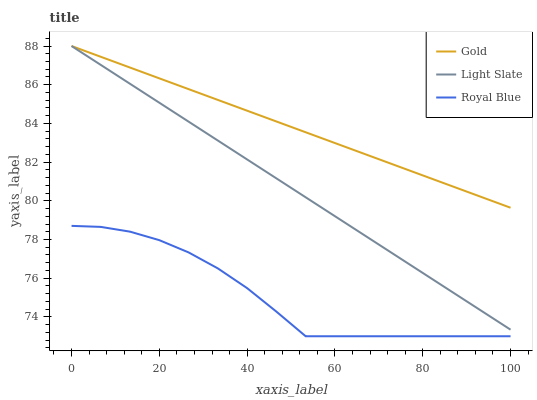Does Royal Blue have the minimum area under the curve?
Answer yes or no. Yes. Does Gold have the maximum area under the curve?
Answer yes or no. Yes. Does Gold have the minimum area under the curve?
Answer yes or no. No. Does Royal Blue have the maximum area under the curve?
Answer yes or no. No. Is Gold the smoothest?
Answer yes or no. Yes. Is Royal Blue the roughest?
Answer yes or no. Yes. Is Royal Blue the smoothest?
Answer yes or no. No. Is Gold the roughest?
Answer yes or no. No. Does Royal Blue have the lowest value?
Answer yes or no. Yes. Does Gold have the lowest value?
Answer yes or no. No. Does Gold have the highest value?
Answer yes or no. Yes. Does Royal Blue have the highest value?
Answer yes or no. No. Is Royal Blue less than Light Slate?
Answer yes or no. Yes. Is Gold greater than Royal Blue?
Answer yes or no. Yes. Does Light Slate intersect Gold?
Answer yes or no. Yes. Is Light Slate less than Gold?
Answer yes or no. No. Is Light Slate greater than Gold?
Answer yes or no. No. Does Royal Blue intersect Light Slate?
Answer yes or no. No. 